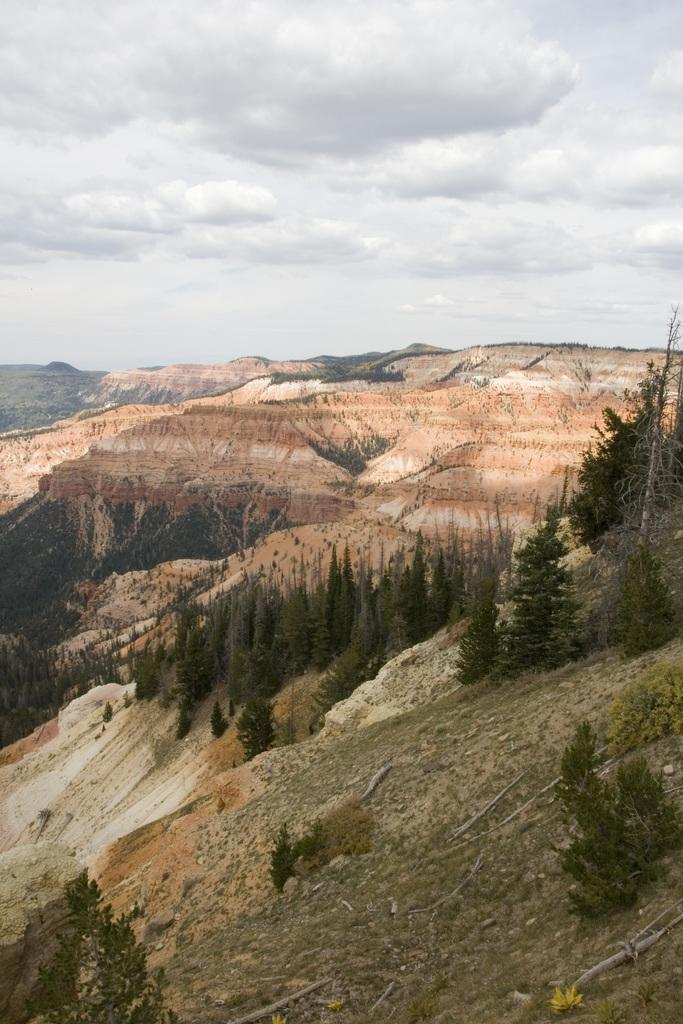What type of landscape is depicted in the image? The image contains a hill view. What can be seen on the hill in the image? There are trees on the hill. What is visible at the top of the image? The sky is visible at the top of the image. What health benefits can be gained from the flavor of the hill in the image? The image does not depict a flavor or any health benefits associated with it. 